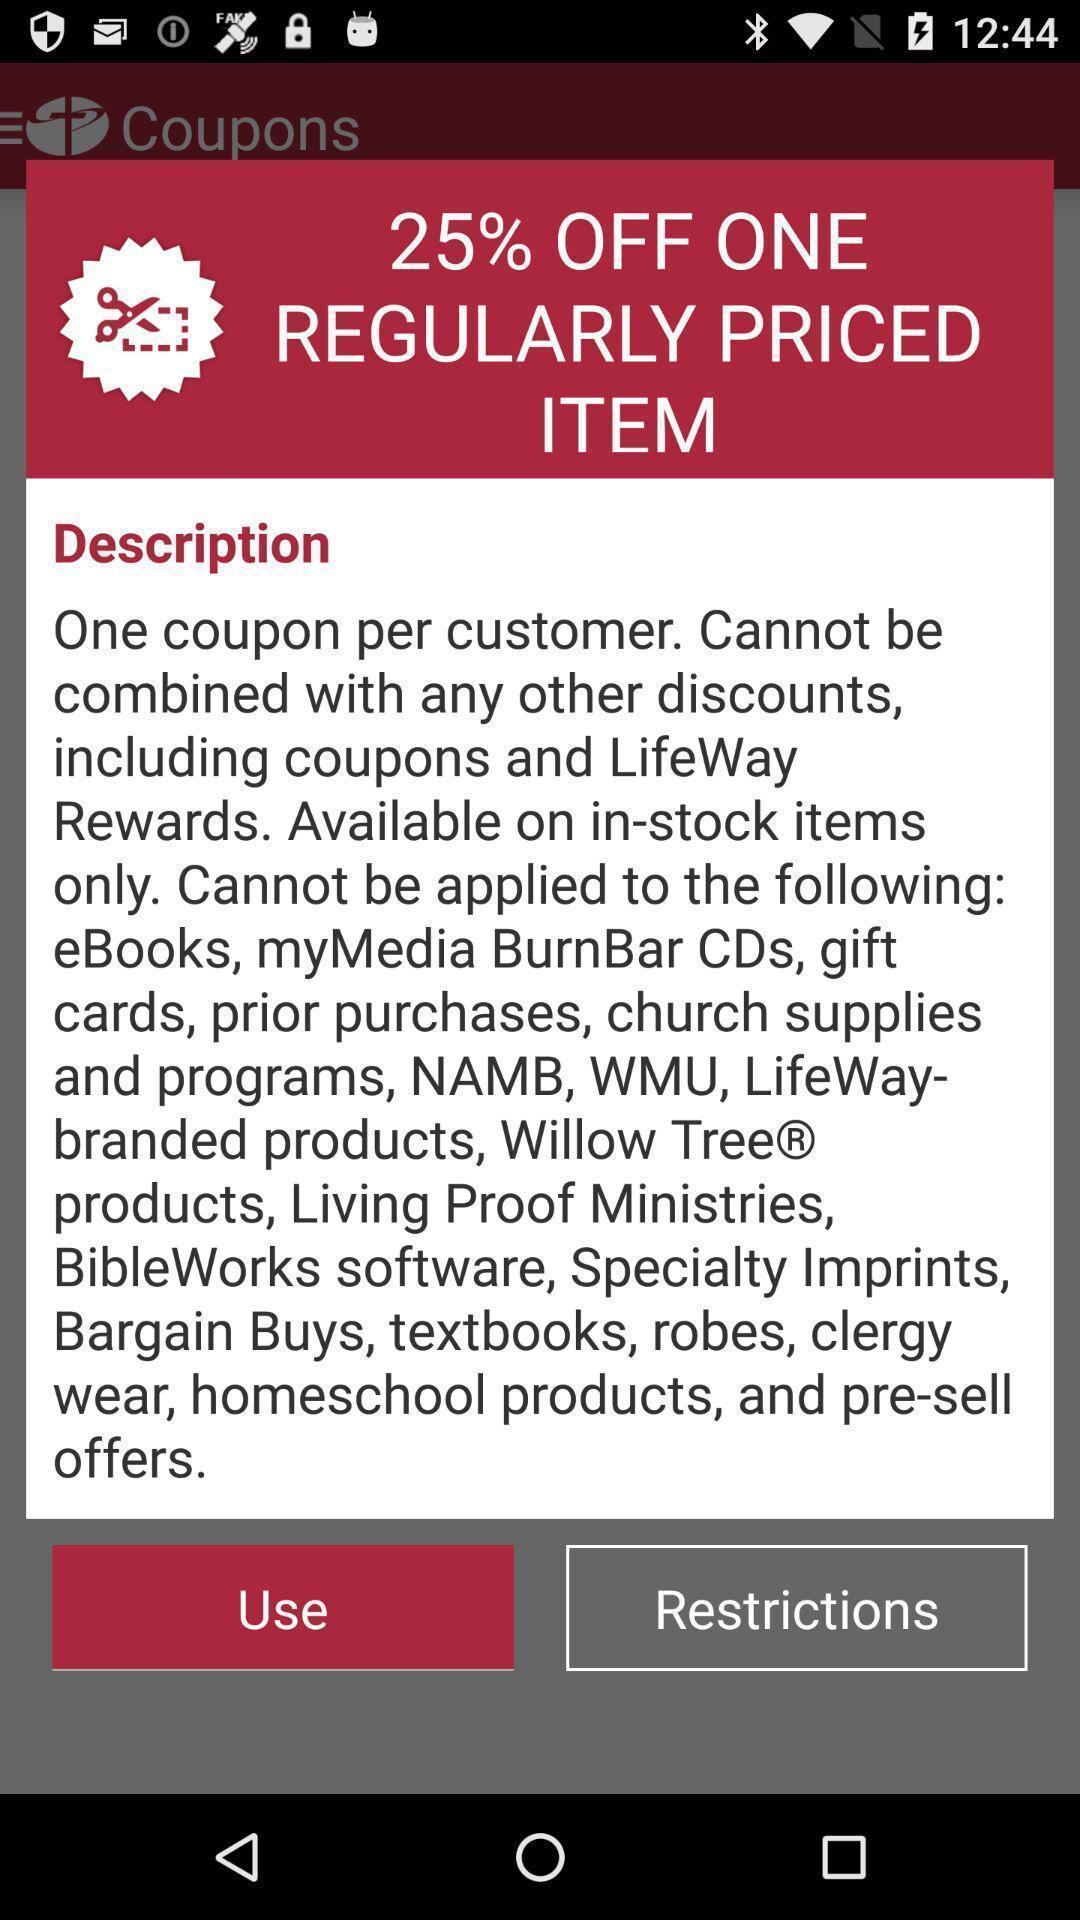Provide a textual representation of this image. Popup displaying description. 